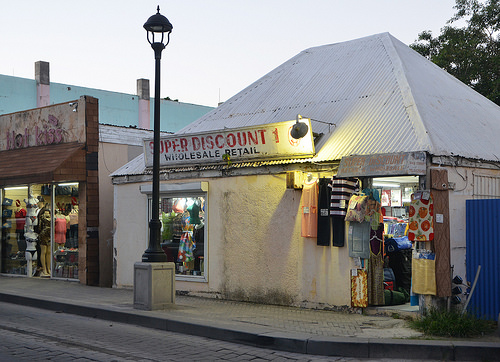<image>
Is there a pole behind the store? No. The pole is not behind the store. From this viewpoint, the pole appears to be positioned elsewhere in the scene. 